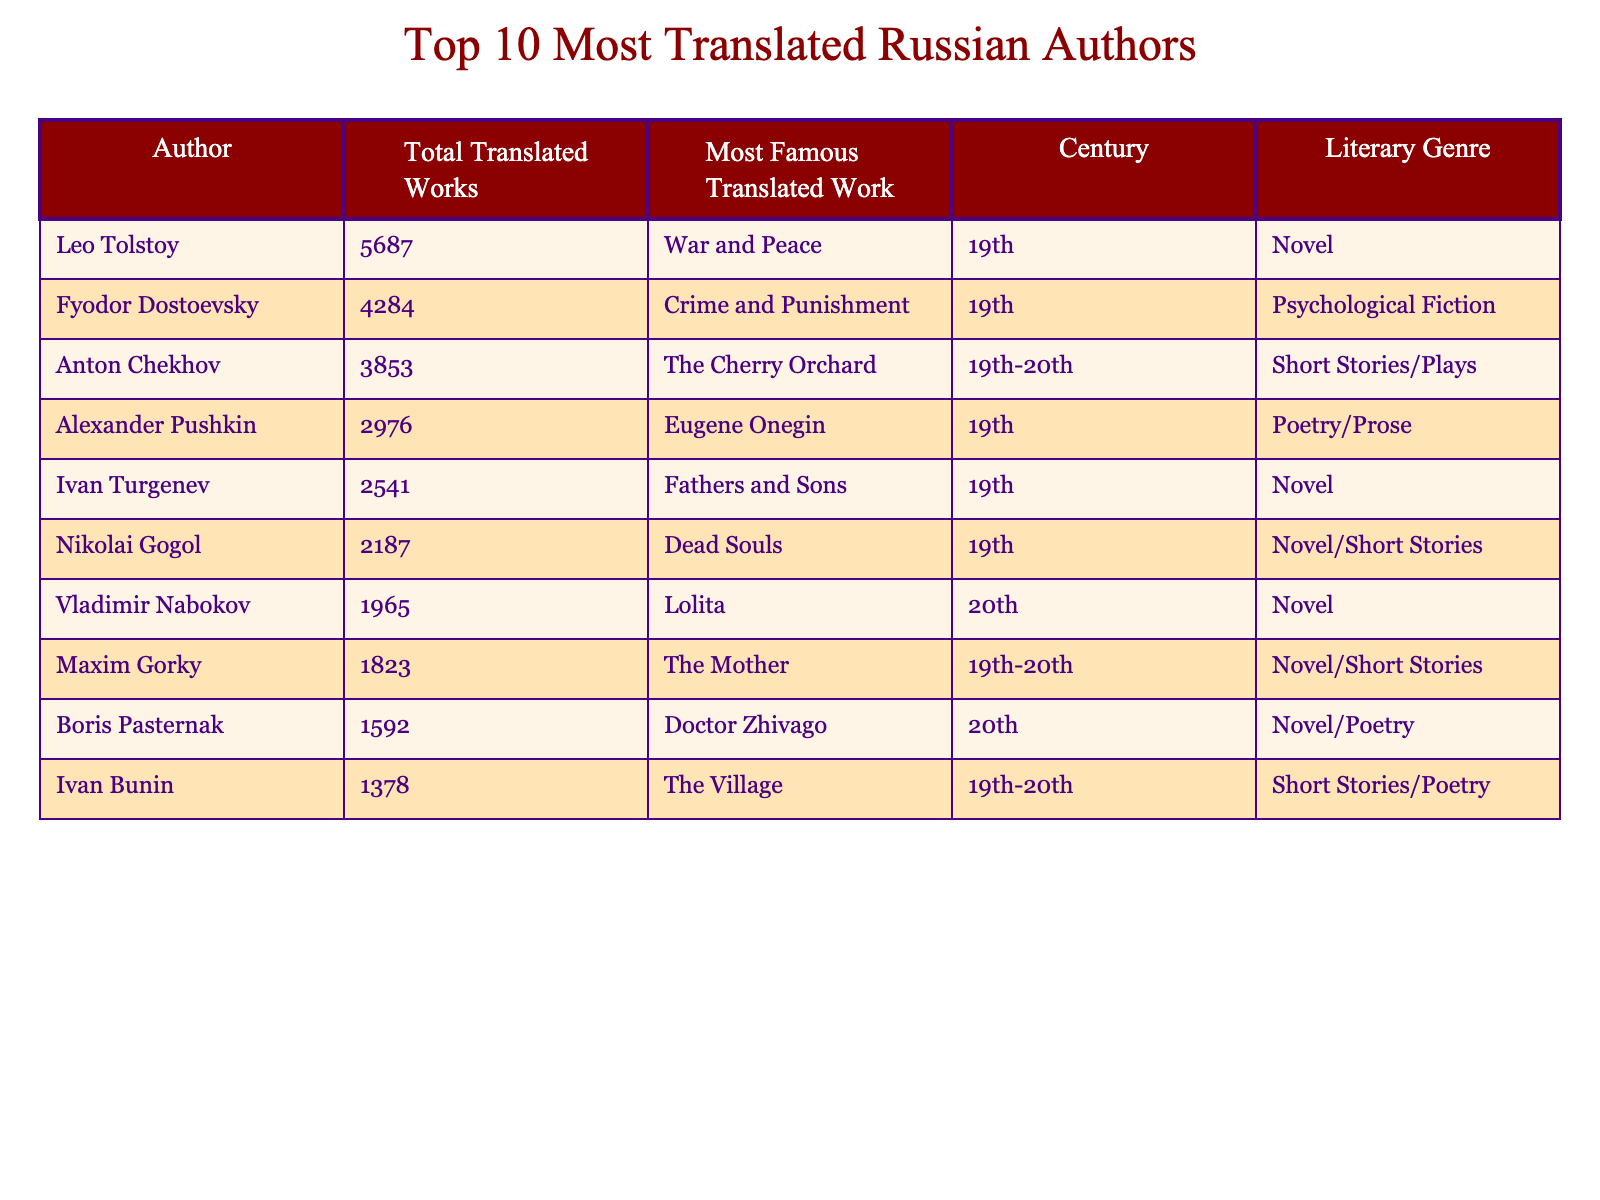What is the total number of translated works by Leo Tolstoy? The table lists the total translated works for each author. For Leo Tolstoy, it shows that he has 5687 translated works.
Answer: 5687 Which author is known for "Crime and Punishment"? The table indicates that Fyodor Dostoevsky's most famous translated work is "Crime and Punishment."
Answer: Fyodor Dostoevsky What is the average number of translated works for the top three authors? The sum of the total translated works for the top three authors (Tolstoy, Dostoevsky, and Chekhov) is 5687 + 4284 + 3853 = 13824. Dividing this sum by three gives us an average of 13824 / 3 = 4608.
Answer: 4608 Is "The Mother" written by a 19th-century author? According to the table, "The Mother" is a work by Maxim Gorky, who is classified as a 19th-20th century author, so the answer is no.
Answer: No What is the difference in the number of translated works between Alexander Pushkin and Ivan Bunin? Alexander Pushkin has 2976 translated works, while Ivan Bunin has 1378. To find the difference, we subtract: 2976 - 1378 = 1598.
Answer: 1598 How many authors have translated works in the 20th century? The table shows that Vladimir Nabokov and Boris Pasternak are 20th-century authors among the top ten, so there are two such authors.
Answer: 2 Which author has the least number of translated works? By examining the table, we see that Ivan Bunin has the least number of translated works, with a total of 1378.
Answer: Ivan Bunin What percentage of the total translated works do Anton Chekhov's works represent? First, we need the total number of translated works across all authors: 5687 + 4284 + 3853 + 2976 + 2541 + 2187 + 1965 + 1823 + 1592 + 1378 = 20056. Anton Chekhov has 3853 works, so the percentage is (3853 / 20056) * 100 ≈ 19.2%.
Answer: 19.2% Which literary genre is the most represented among the top 10 authors? Looking at the list, both "Novel" and "Short Stories/Plays" have multiple authors associated with them, but "Novel" appears for more authors (Tolstoy, Turgenev, Gogol, Nabokov, Gorky, Pasternak). Thus, it's the most represented genre.
Answer: Novel Are there more authors known for poetry than for novels in this list? The table shows that multiple authors are known primarily for novels (6 authors) while only 2 are known specifically for poetry/prose (Pushkin and Pasternak). Therefore, there are more authors known for novels.
Answer: No 